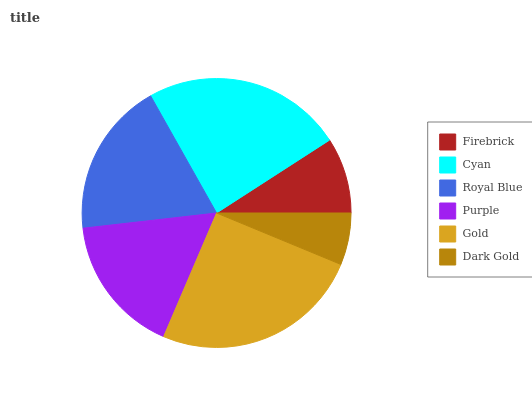Is Dark Gold the minimum?
Answer yes or no. Yes. Is Gold the maximum?
Answer yes or no. Yes. Is Cyan the minimum?
Answer yes or no. No. Is Cyan the maximum?
Answer yes or no. No. Is Cyan greater than Firebrick?
Answer yes or no. Yes. Is Firebrick less than Cyan?
Answer yes or no. Yes. Is Firebrick greater than Cyan?
Answer yes or no. No. Is Cyan less than Firebrick?
Answer yes or no. No. Is Royal Blue the high median?
Answer yes or no. Yes. Is Purple the low median?
Answer yes or no. Yes. Is Gold the high median?
Answer yes or no. No. Is Royal Blue the low median?
Answer yes or no. No. 